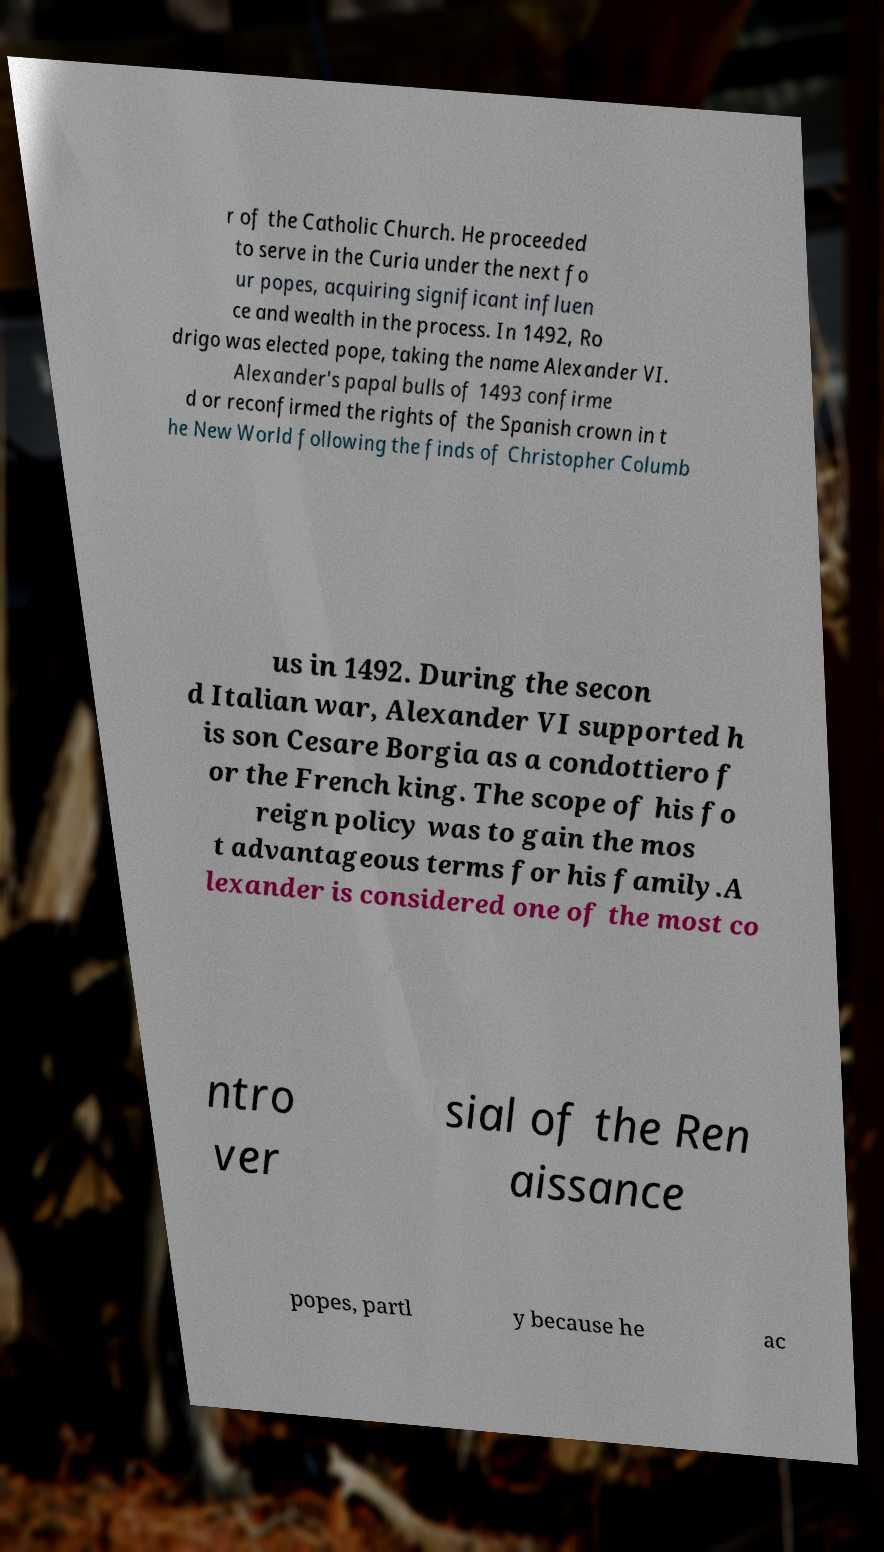Could you assist in decoding the text presented in this image and type it out clearly? r of the Catholic Church. He proceeded to serve in the Curia under the next fo ur popes, acquiring significant influen ce and wealth in the process. In 1492, Ro drigo was elected pope, taking the name Alexander VI. Alexander's papal bulls of 1493 confirme d or reconfirmed the rights of the Spanish crown in t he New World following the finds of Christopher Columb us in 1492. During the secon d Italian war, Alexander VI supported h is son Cesare Borgia as a condottiero f or the French king. The scope of his fo reign policy was to gain the mos t advantageous terms for his family.A lexander is considered one of the most co ntro ver sial of the Ren aissance popes, partl y because he ac 